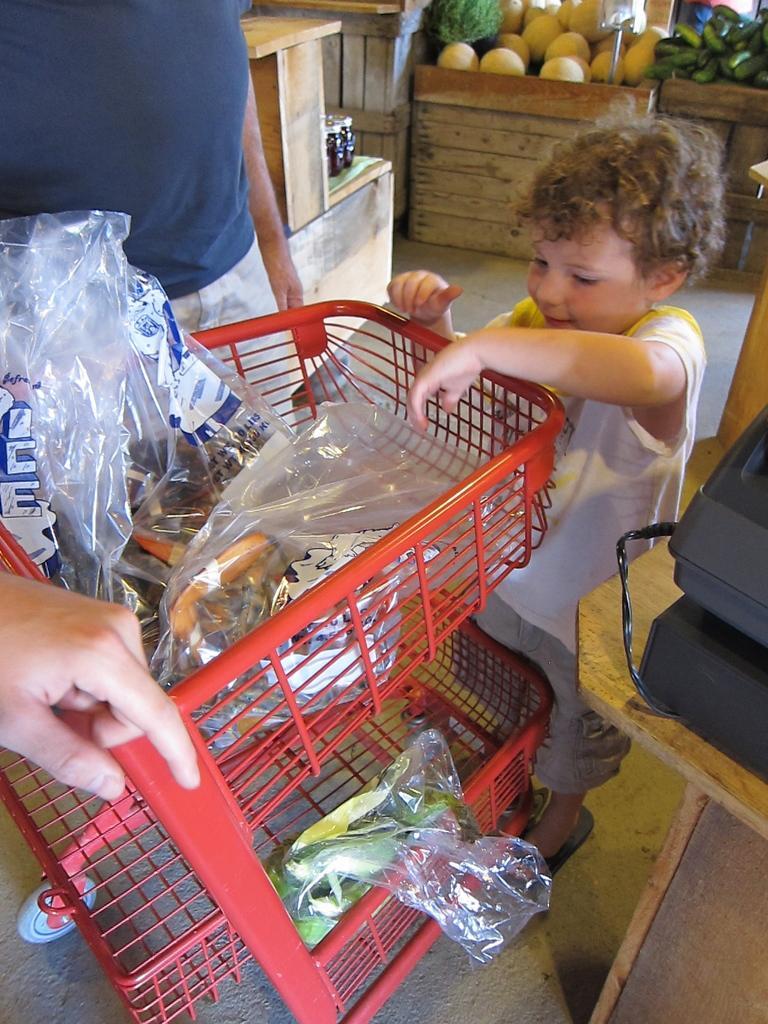Could you give a brief overview of what you see in this image? In this image I can see two people in-front of the red color trolley. I can see the plastic covers with some objects in the trolley. To the right I can see the black color object on the table. In the background I can see the vegetables in the baskets. To the left I can see the hand of one more person. 